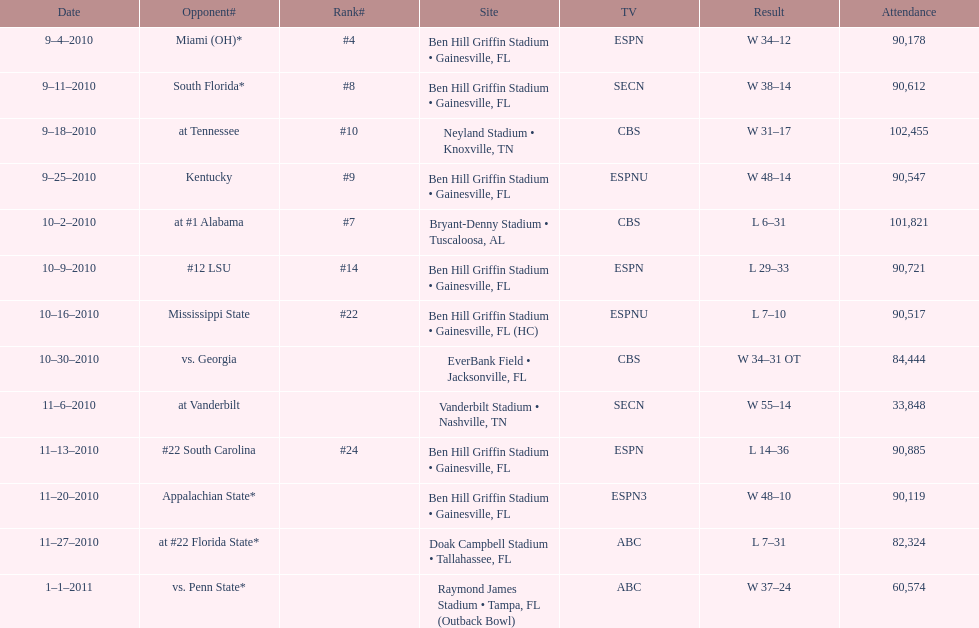What is the number of games played in teh 2010-2011 season 13. 